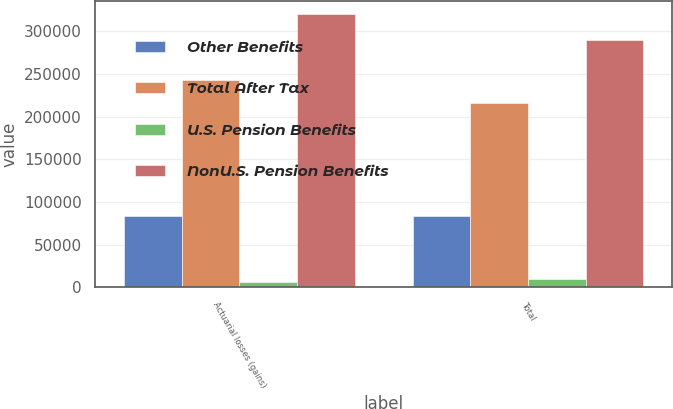<chart> <loc_0><loc_0><loc_500><loc_500><stacked_bar_chart><ecel><fcel>Actuarial losses (gains)<fcel>Total<nl><fcel>Other Benefits<fcel>83347<fcel>83347<nl><fcel>Total After Tax<fcel>243338<fcel>216224<nl><fcel>U.S. Pension Benefits<fcel>6915<fcel>9943<nl><fcel>NonU.S. Pension Benefits<fcel>319770<fcel>289628<nl></chart> 